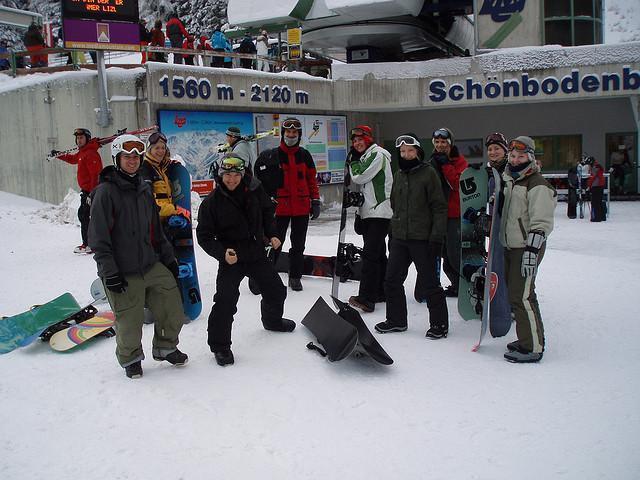How many people are actively wearing their goggles?
Give a very brief answer. 0. How many people are there?
Give a very brief answer. 10. How many snowboards can you see?
Give a very brief answer. 2. 